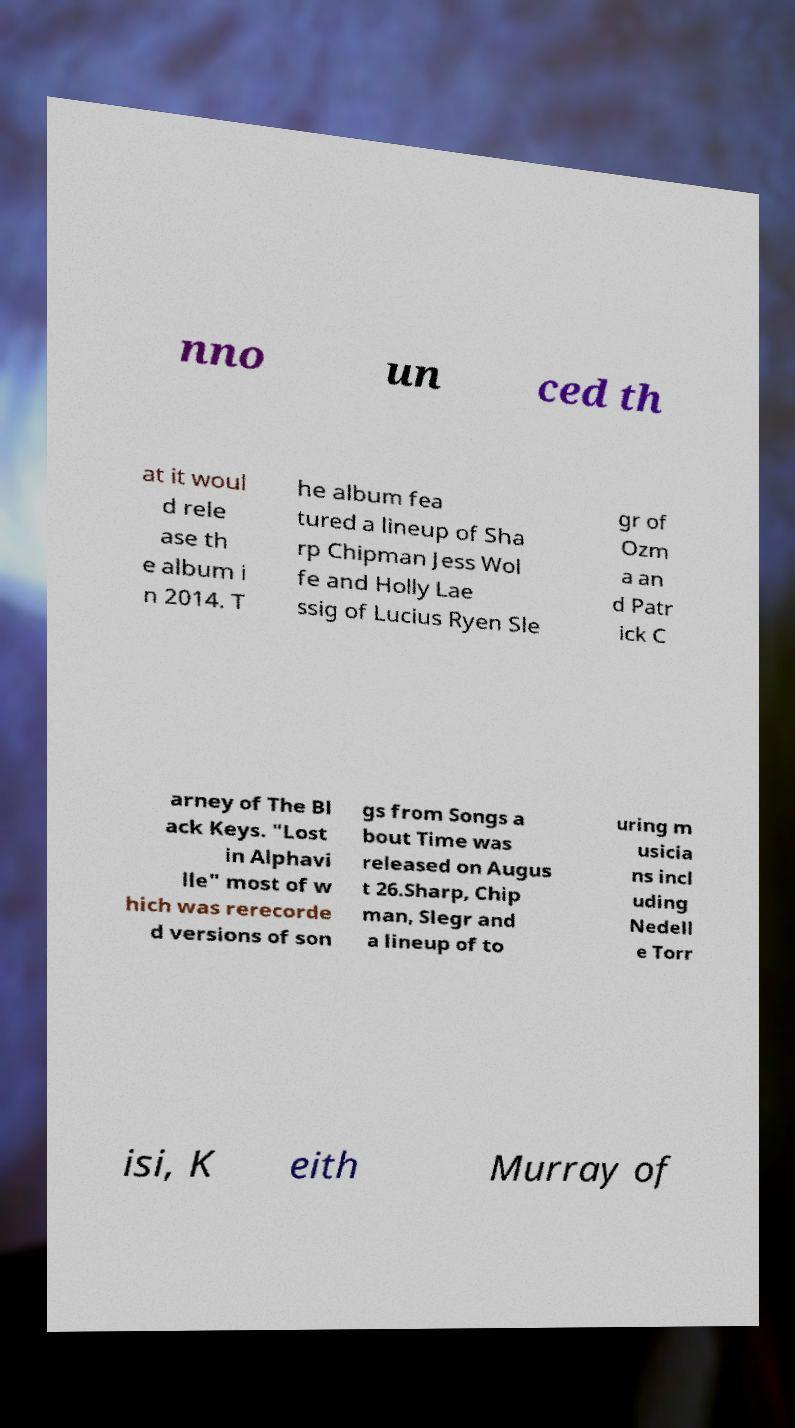What messages or text are displayed in this image? I need them in a readable, typed format. nno un ced th at it woul d rele ase th e album i n 2014. T he album fea tured a lineup of Sha rp Chipman Jess Wol fe and Holly Lae ssig of Lucius Ryen Sle gr of Ozm a an d Patr ick C arney of The Bl ack Keys. "Lost in Alphavi lle" most of w hich was rerecorde d versions of son gs from Songs a bout Time was released on Augus t 26.Sharp, Chip man, Slegr and a lineup of to uring m usicia ns incl uding Nedell e Torr isi, K eith Murray of 